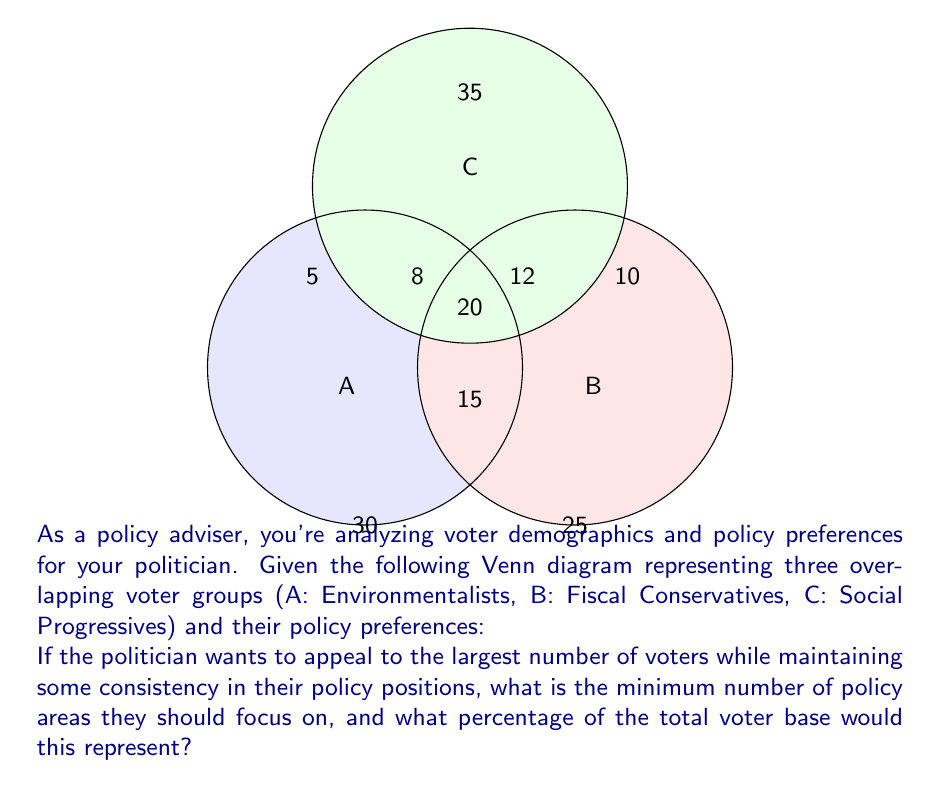Show me your answer to this math problem. Let's approach this step-by-step:

1) First, we need to calculate the total number of voters:
   $$30 + 25 + 35 + 5 + 10 + 15 + 8 + 12 + 20 = 160$$

2) To appeal to the largest number of voters while maintaining some consistency, we should look for the largest overlapping areas:

   a) A ∩ B ∩ C (center): 20 voters
   b) A ∩ C (top left): 8 voters
   c) B ∩ C (top right): 12 drivers

3) By focusing on these three overlapping areas, the politician can appeal to:
   $$20 + 8 + 12 = 40$$ voters

4) To calculate the percentage, we use:
   $$\frac{\text{Voters appealed to}}{\text{Total voters}} \times 100\% = \frac{40}{160} \times 100\% = 25\%$$

5) Therefore, by focusing on 3 policy areas that appeal to these overlapping groups, the politician can reach 25% of the total voter base while maintaining some consistency in their positions.
Answer: 3 policy areas; 25% of voters 